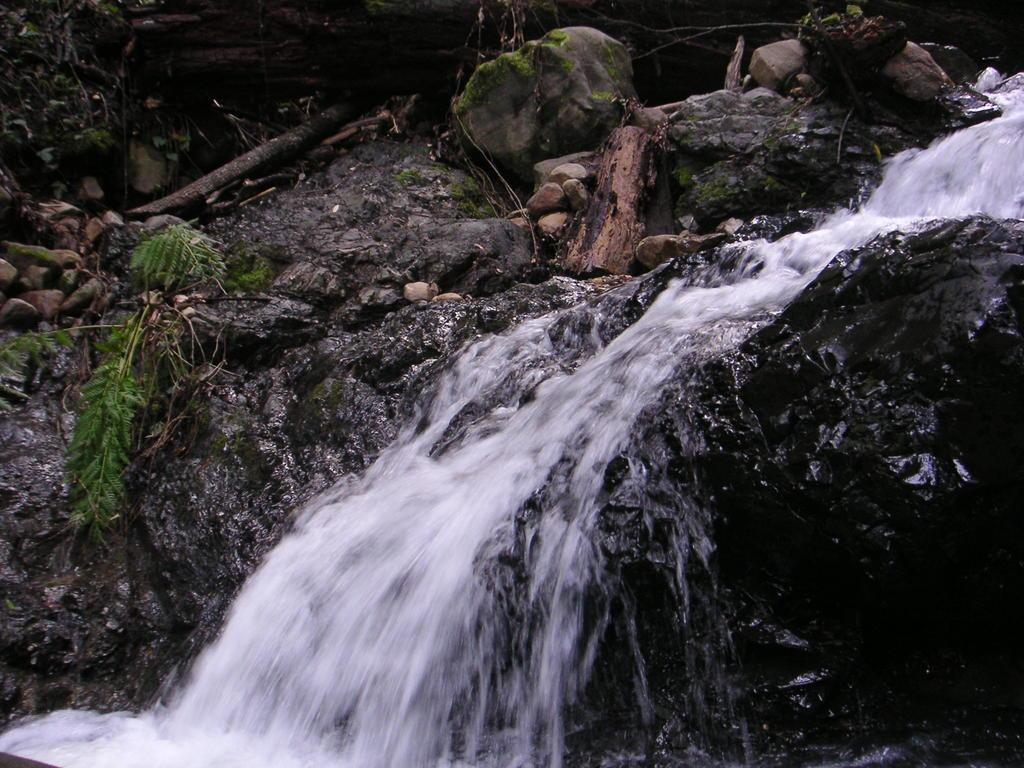What natural feature is the main subject of the image? There is a waterfall in the image. What type of vegetation can be seen in the image? There are plants in the image. What type of material are the stones made of? The stones are made of rock. What other objects are visible in the image? Wooden pieces are visible in the image. What time of day is it in the image, and where is the brother? The time of day is not mentioned in the image, and there is no brother present in the image. 